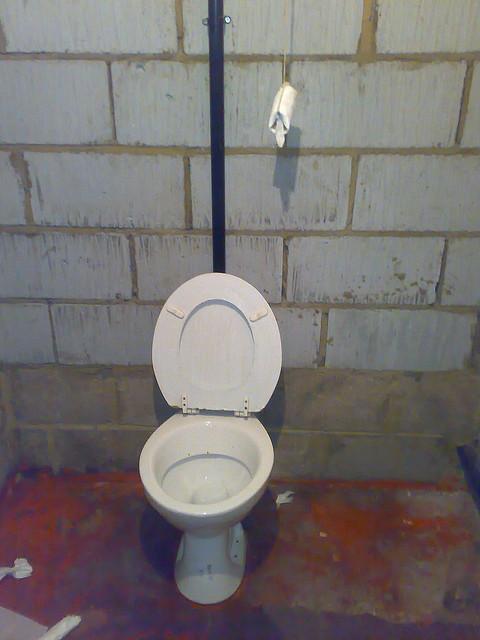What is on the floor?
Short answer required. Paint. Is the toilet seat up or down?
Concise answer only. Up. What is behind the toilet?
Quick response, please. Wall. Is this a city sidewalk?
Give a very brief answer. No. What color is the toilet?
Give a very brief answer. White. Is the lid down?
Keep it brief. No. Does this place look pretty unsanitary?
Answer briefly. Yes. What color is the hose?
Quick response, please. Black. 